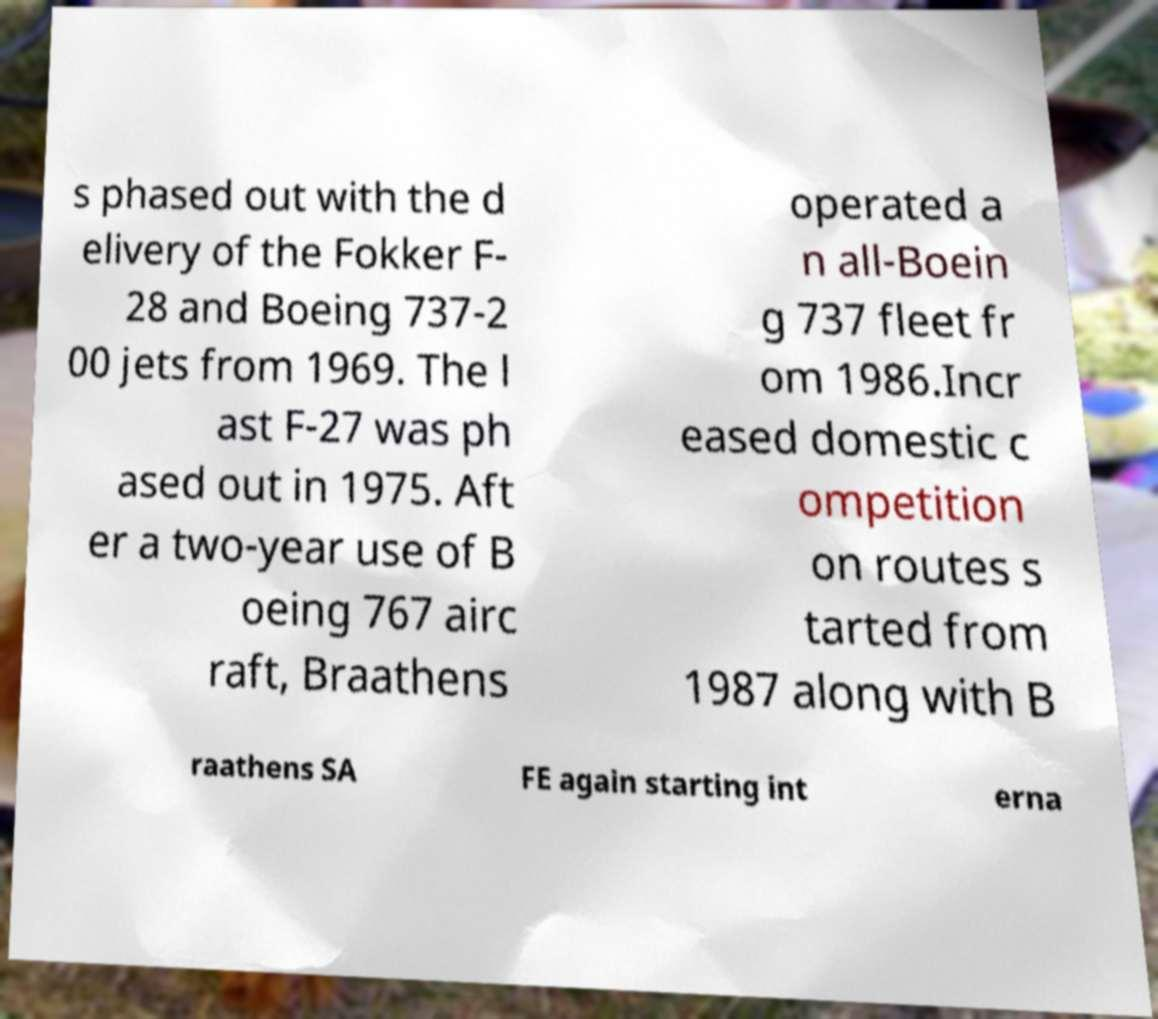Could you assist in decoding the text presented in this image and type it out clearly? s phased out with the d elivery of the Fokker F- 28 and Boeing 737-2 00 jets from 1969. The l ast F-27 was ph ased out in 1975. Aft er a two-year use of B oeing 767 airc raft, Braathens operated a n all-Boein g 737 fleet fr om 1986.Incr eased domestic c ompetition on routes s tarted from 1987 along with B raathens SA FE again starting int erna 